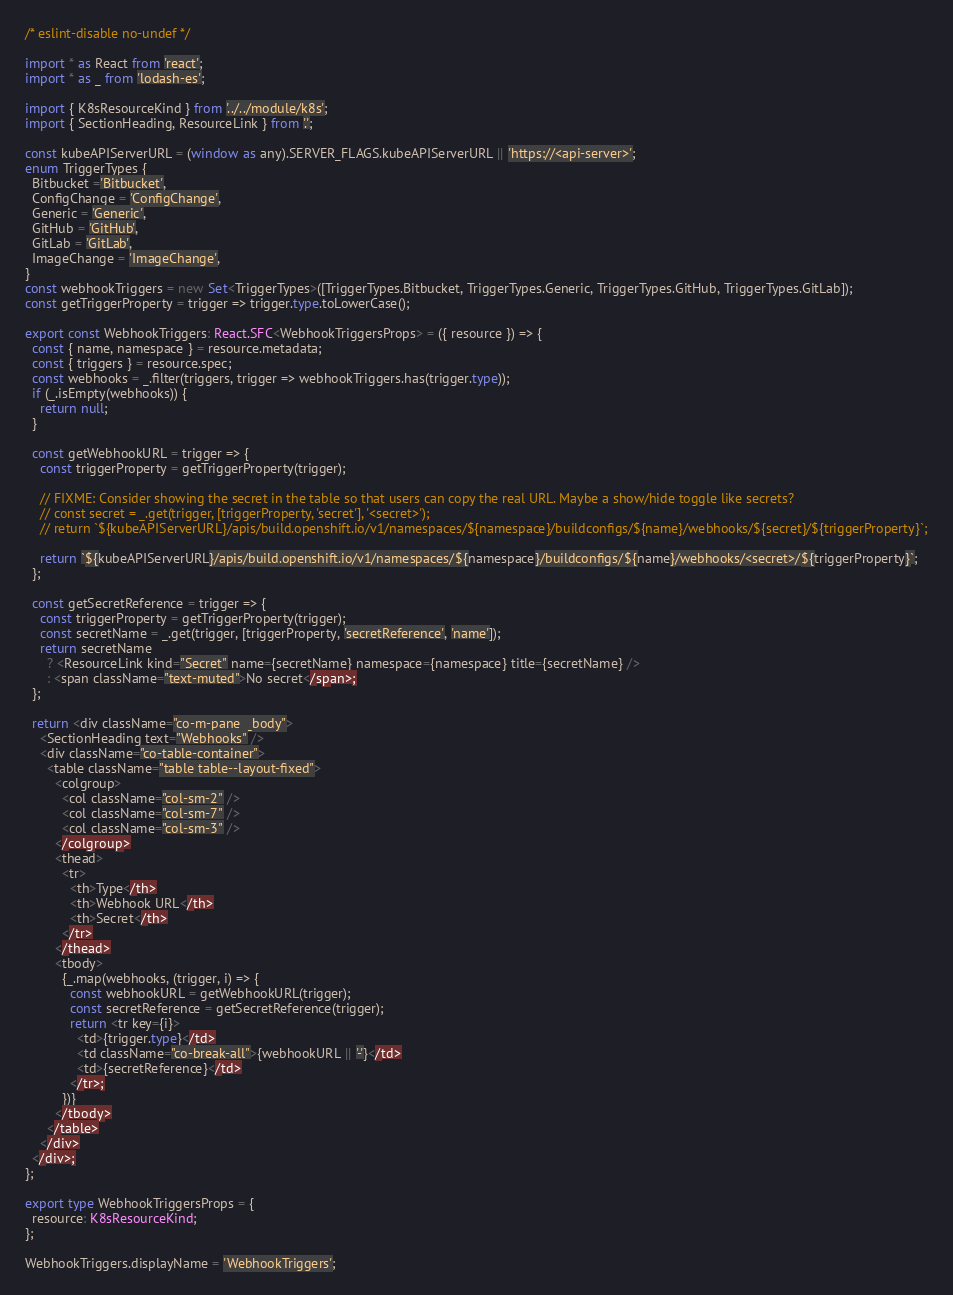Convert code to text. <code><loc_0><loc_0><loc_500><loc_500><_TypeScript_>/* eslint-disable no-undef */

import * as React from 'react';
import * as _ from 'lodash-es';

import { K8sResourceKind } from '../../module/k8s';
import { SectionHeading, ResourceLink } from '.';

const kubeAPIServerURL = (window as any).SERVER_FLAGS.kubeAPIServerURL || 'https://<api-server>';
enum TriggerTypes {
  Bitbucket ='Bitbucket',
  ConfigChange = 'ConfigChange',
  Generic = 'Generic',
  GitHub = 'GitHub',
  GitLab = 'GitLab',
  ImageChange = 'ImageChange',
}
const webhookTriggers = new Set<TriggerTypes>([TriggerTypes.Bitbucket, TriggerTypes.Generic, TriggerTypes.GitHub, TriggerTypes.GitLab]);
const getTriggerProperty = trigger => trigger.type.toLowerCase();

export const WebhookTriggers: React.SFC<WebhookTriggersProps> = ({ resource }) => {
  const { name, namespace } = resource.metadata;
  const { triggers } = resource.spec;
  const webhooks = _.filter(triggers, trigger => webhookTriggers.has(trigger.type));
  if (_.isEmpty(webhooks)) {
    return null;
  }

  const getWebhookURL = trigger => {
    const triggerProperty = getTriggerProperty(trigger);

    // FIXME: Consider showing the secret in the table so that users can copy the real URL. Maybe a show/hide toggle like secrets?
    // const secret = _.get(trigger, [triggerProperty, 'secret'], '<secret>');
    // return `${kubeAPIServerURL}/apis/build.openshift.io/v1/namespaces/${namespace}/buildconfigs/${name}/webhooks/${secret}/${triggerProperty}`;

    return `${kubeAPIServerURL}/apis/build.openshift.io/v1/namespaces/${namespace}/buildconfigs/${name}/webhooks/<secret>/${triggerProperty}`;
  };

  const getSecretReference = trigger => {
    const triggerProperty = getTriggerProperty(trigger);
    const secretName = _.get(trigger, [triggerProperty, 'secretReference', 'name']);
    return secretName
      ? <ResourceLink kind="Secret" name={secretName} namespace={namespace} title={secretName} />
      : <span className="text-muted">No secret</span>;
  };

  return <div className="co-m-pane__body">
    <SectionHeading text="Webhooks" />
    <div className="co-table-container">
      <table className="table table--layout-fixed">
        <colgroup>
          <col className="col-sm-2" />
          <col className="col-sm-7" />
          <col className="col-sm-3" />
        </colgroup>
        <thead>
          <tr>
            <th>Type</th>
            <th>Webhook URL</th>
            <th>Secret</th>
          </tr>
        </thead>
        <tbody>
          {_.map(webhooks, (trigger, i) => {
            const webhookURL = getWebhookURL(trigger);
            const secretReference = getSecretReference(trigger);
            return <tr key={i}>
              <td>{trigger.type}</td>
              <td className="co-break-all">{webhookURL || '-'}</td>
              <td>{secretReference}</td>
            </tr>;
          })}
        </tbody>
      </table>
    </div>
  </div>;
};

export type WebhookTriggersProps = {
  resource: K8sResourceKind;
};

WebhookTriggers.displayName = 'WebhookTriggers';
</code> 